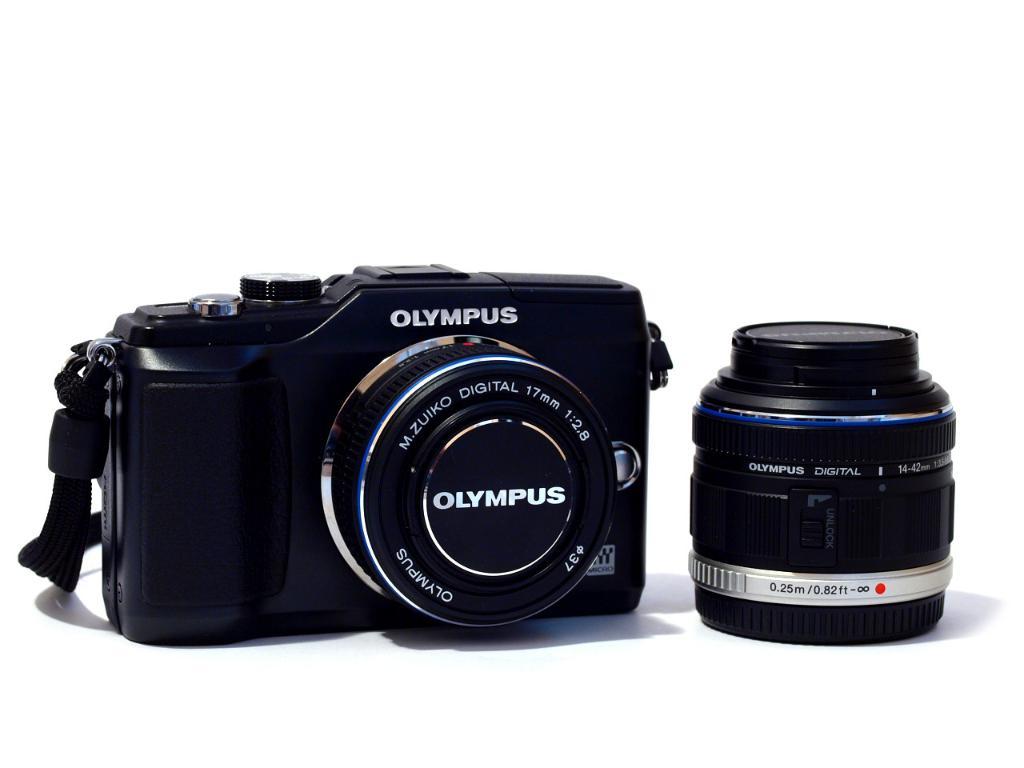Is that an olympus camera?
Give a very brief answer. Yes. What type is the olympus camera?
Keep it short and to the point. Digital. 